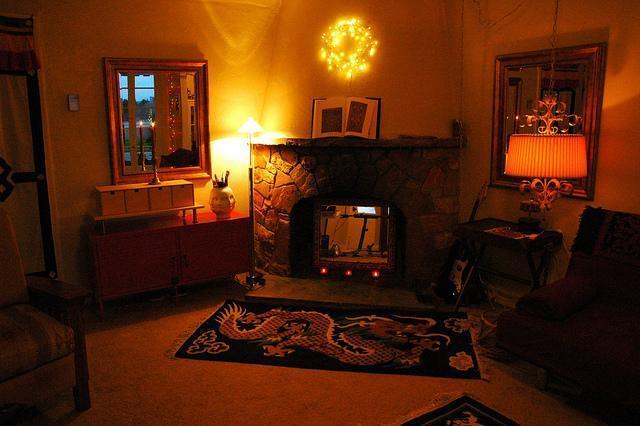How many mirrors in the room?
Give a very brief answer. 2. 